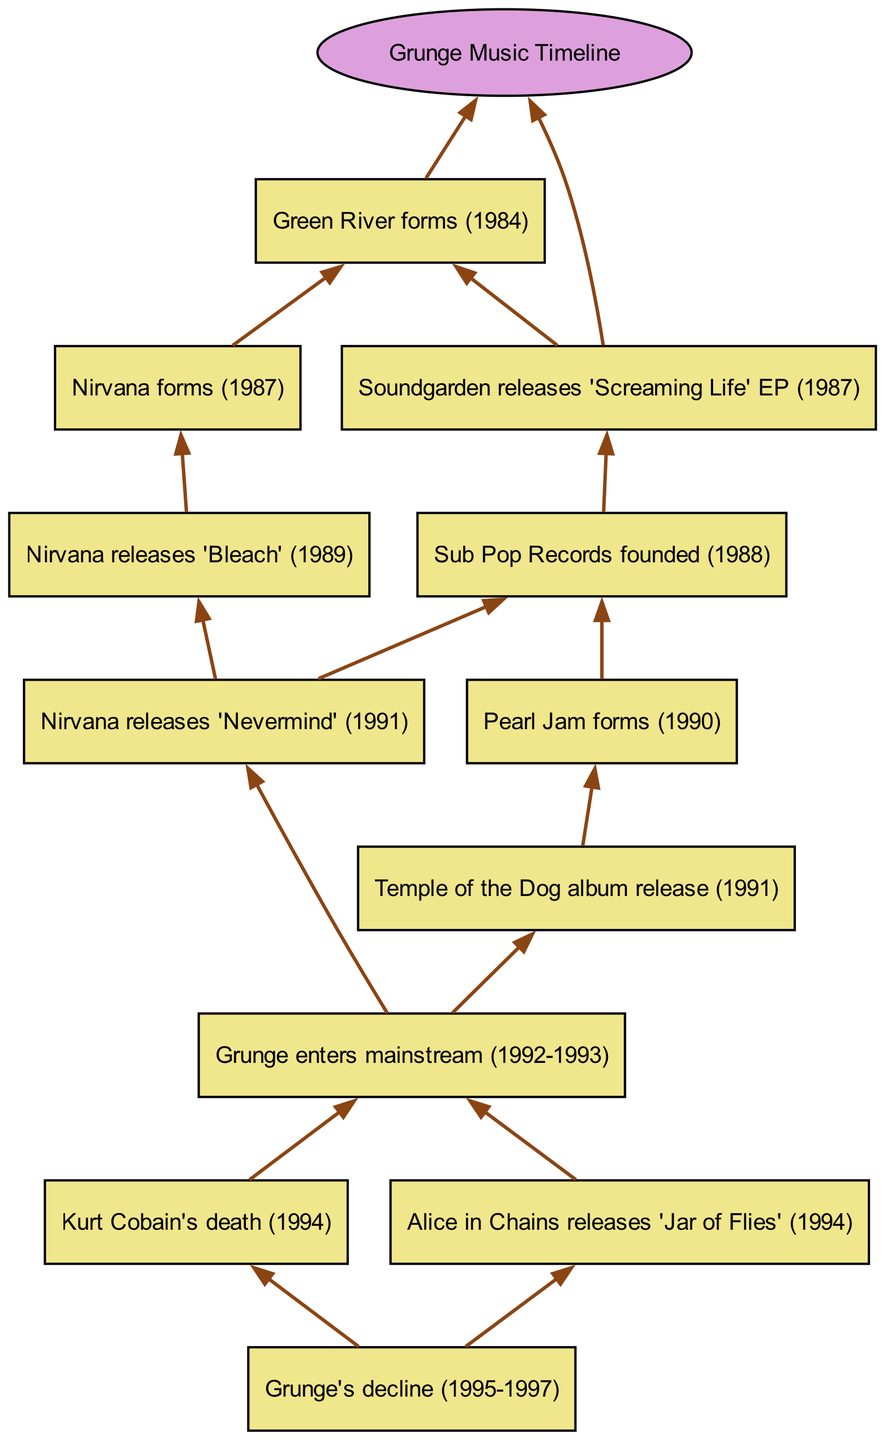What year did Nirvana release 'Nevermind'? The diagram shows that Nirvana releases 'Nevermind' in 1991, which is clearly indicated in the node corresponding to that event.
Answer: 1991 How many albums does Alice in Chains release, according to the diagram? There is one direct mention in the diagram that Alice in Chains releases 'Jar of Flies' in 1994. Thus, based on the flowchart, they released one album.
Answer: 1 What is the first event listed in the timeline? The flowchart starts with the formation of Green River, which is the earliest event in the timeline, occurring in 1984.
Answer: Green River forms (1984) Which band is linked to the year 1990 in the diagram? The diagram includes the formation of Pearl Jam in 1990. This is the only band mentioned in that year within the timeline structure.
Answer: Pearl Jam Which two events directly led to Grunge entering the mainstream? The diagram indicates that both Nirvana releasing 'Nevermind' in 1991 and the release of Temple of the Dog's album in 1991 are critical events that contribute to grunge entering the mainstream, which spans 1992-1993.
Answer: Nirvana releases 'Nevermind' (1991) and Temple of the Dog album release (1991) How are the events after Kurt Cobain's death displayed in the timeline? The diagram shows that after Kurt Cobain's death in 1994, there is an edge directed towards the decline of grunge reflected in the following node labeled 'Grunge's decline (1995-1997)', indicating a direct consequence of his passing on the grunge scene.
Answer: Grunge's decline (1995-1997) What is the last event in the timeline? Grunge's decline from 1995 to 1997 is shown as the final node in the diagram, indicating the end of the timeline's focus on grunge music.
Answer: Grunge's decline (1995-1997) What type of records did Sub Pop Records specialize in, according to the timeline? The diagram mentions the establishment of Sub Pop Records in 1988, suggesting a pivotal role in the emergence of grunge music and connecting it to the bands highlighted in the timeline.
Answer: Grunge records How many children nodes does the event of 'Grunge enters mainstream' have? The diagram shows that 'Grunge enters mainstream' has two children nodes, which are Kurt Cobain's death and Alice in Chains releasing 'Jar of Flies', indicating the complex aftermath and developments during that period.
Answer: 2 